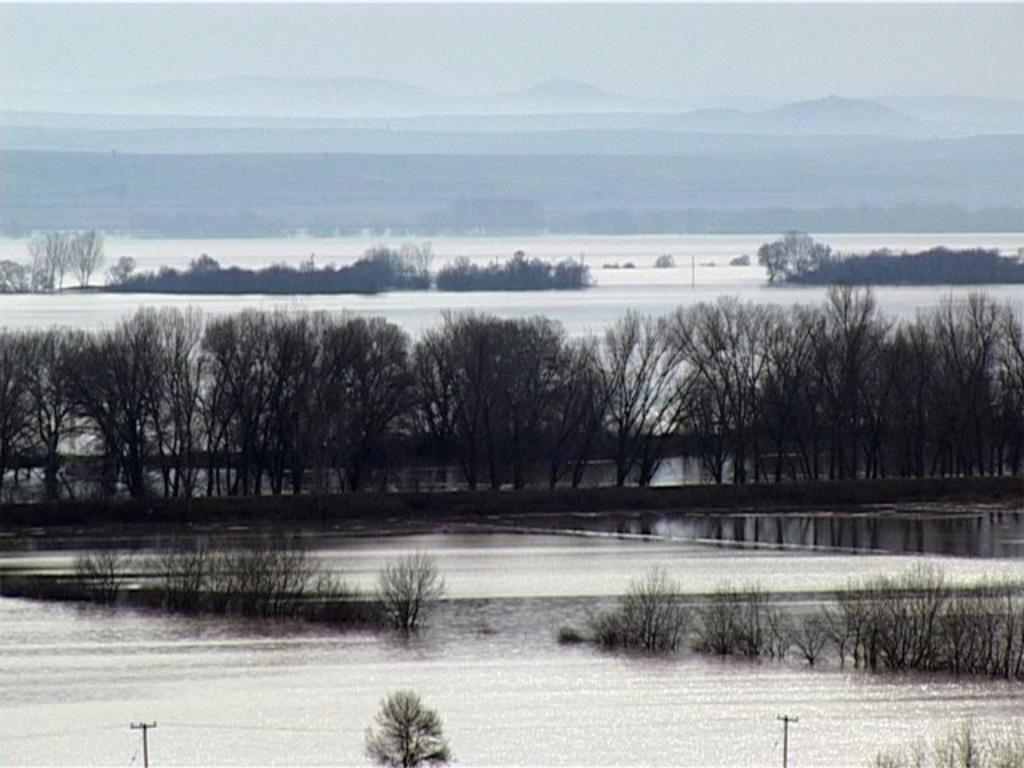What is the primary element in the image? There is water in the image. What can be seen in the background of the image? There are trees and mountains in the background of the image. How is the snow described in the image? The snow is described as white in the image. What part of the natural environment is visible in the image? The sky is visible in the image and is also described as white. Can you describe the color of the bee in the image? There is no bee present in the image. How does the snail move across the snow in the image? There is no snail present in the image. 